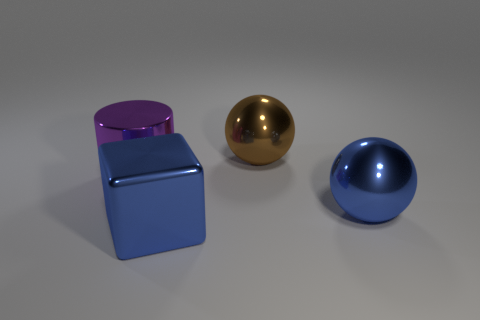Add 2 large gray rubber cubes. How many objects exist? 6 Subtract all cylinders. How many objects are left? 3 Add 1 large blue objects. How many large blue objects are left? 3 Add 4 blue balls. How many blue balls exist? 5 Subtract 0 red spheres. How many objects are left? 4 Subtract all large brown metallic objects. Subtract all brown shiny spheres. How many objects are left? 2 